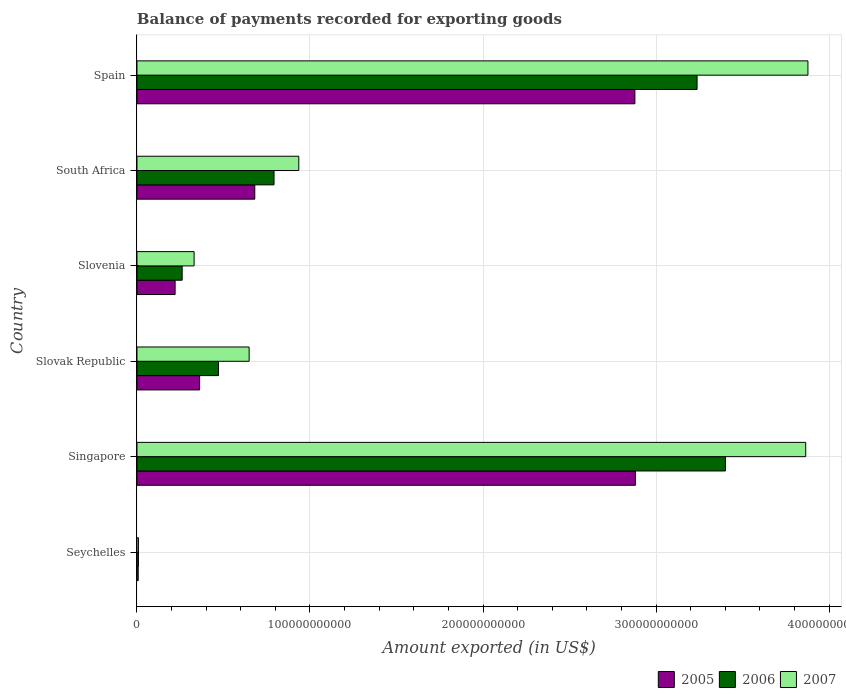Are the number of bars on each tick of the Y-axis equal?
Your answer should be compact. Yes. How many bars are there on the 4th tick from the bottom?
Provide a succinct answer. 3. What is the label of the 2nd group of bars from the top?
Offer a terse response. South Africa. In how many cases, is the number of bars for a given country not equal to the number of legend labels?
Your response must be concise. 0. What is the amount exported in 2005 in Slovak Republic?
Provide a succinct answer. 3.62e+1. Across all countries, what is the maximum amount exported in 2006?
Provide a succinct answer. 3.40e+11. Across all countries, what is the minimum amount exported in 2006?
Your response must be concise. 8.50e+08. In which country was the amount exported in 2007 maximum?
Your answer should be very brief. Spain. In which country was the amount exported in 2007 minimum?
Your answer should be compact. Seychelles. What is the total amount exported in 2005 in the graph?
Make the answer very short. 7.03e+11. What is the difference between the amount exported in 2007 in Singapore and that in Slovenia?
Give a very brief answer. 3.53e+11. What is the difference between the amount exported in 2006 in Slovenia and the amount exported in 2005 in Seychelles?
Make the answer very short. 2.54e+1. What is the average amount exported in 2006 per country?
Give a very brief answer. 1.36e+11. What is the difference between the amount exported in 2005 and amount exported in 2007 in Slovak Republic?
Offer a very short reply. -2.86e+1. In how many countries, is the amount exported in 2005 greater than 260000000000 US$?
Your answer should be very brief. 2. What is the ratio of the amount exported in 2005 in Seychelles to that in Spain?
Your answer should be very brief. 0. Is the amount exported in 2005 in South Africa less than that in Spain?
Provide a short and direct response. Yes. Is the difference between the amount exported in 2005 in Seychelles and Spain greater than the difference between the amount exported in 2007 in Seychelles and Spain?
Ensure brevity in your answer.  Yes. What is the difference between the highest and the second highest amount exported in 2007?
Your response must be concise. 1.29e+09. What is the difference between the highest and the lowest amount exported in 2007?
Keep it short and to the point. 3.87e+11. Is the sum of the amount exported in 2007 in Seychelles and Slovak Republic greater than the maximum amount exported in 2006 across all countries?
Provide a succinct answer. No. What does the 2nd bar from the top in Slovak Republic represents?
Keep it short and to the point. 2006. How many countries are there in the graph?
Ensure brevity in your answer.  6. What is the difference between two consecutive major ticks on the X-axis?
Provide a short and direct response. 1.00e+11. Are the values on the major ticks of X-axis written in scientific E-notation?
Your answer should be very brief. No. Does the graph contain any zero values?
Offer a terse response. No. What is the title of the graph?
Your response must be concise. Balance of payments recorded for exporting goods. Does "2006" appear as one of the legend labels in the graph?
Keep it short and to the point. Yes. What is the label or title of the X-axis?
Provide a short and direct response. Amount exported (in US$). What is the Amount exported (in US$) of 2005 in Seychelles?
Your answer should be very brief. 7.20e+08. What is the Amount exported (in US$) in 2006 in Seychelles?
Your response must be concise. 8.50e+08. What is the Amount exported (in US$) of 2007 in Seychelles?
Your answer should be compact. 8.54e+08. What is the Amount exported (in US$) of 2005 in Singapore?
Keep it short and to the point. 2.88e+11. What is the Amount exported (in US$) in 2006 in Singapore?
Ensure brevity in your answer.  3.40e+11. What is the Amount exported (in US$) in 2007 in Singapore?
Your answer should be compact. 3.86e+11. What is the Amount exported (in US$) in 2005 in Slovak Republic?
Your response must be concise. 3.62e+1. What is the Amount exported (in US$) of 2006 in Slovak Republic?
Provide a succinct answer. 4.71e+1. What is the Amount exported (in US$) of 2007 in Slovak Republic?
Provide a succinct answer. 6.48e+1. What is the Amount exported (in US$) in 2005 in Slovenia?
Your answer should be very brief. 2.21e+1. What is the Amount exported (in US$) in 2006 in Slovenia?
Keep it short and to the point. 2.61e+1. What is the Amount exported (in US$) in 2007 in Slovenia?
Offer a terse response. 3.30e+1. What is the Amount exported (in US$) of 2005 in South Africa?
Make the answer very short. 6.81e+1. What is the Amount exported (in US$) of 2006 in South Africa?
Your answer should be very brief. 7.92e+1. What is the Amount exported (in US$) in 2007 in South Africa?
Offer a terse response. 9.35e+1. What is the Amount exported (in US$) of 2005 in Spain?
Keep it short and to the point. 2.88e+11. What is the Amount exported (in US$) in 2006 in Spain?
Make the answer very short. 3.24e+11. What is the Amount exported (in US$) of 2007 in Spain?
Make the answer very short. 3.88e+11. Across all countries, what is the maximum Amount exported (in US$) of 2005?
Provide a succinct answer. 2.88e+11. Across all countries, what is the maximum Amount exported (in US$) of 2006?
Your answer should be very brief. 3.40e+11. Across all countries, what is the maximum Amount exported (in US$) in 2007?
Your answer should be very brief. 3.88e+11. Across all countries, what is the minimum Amount exported (in US$) in 2005?
Ensure brevity in your answer.  7.20e+08. Across all countries, what is the minimum Amount exported (in US$) of 2006?
Offer a terse response. 8.50e+08. Across all countries, what is the minimum Amount exported (in US$) of 2007?
Keep it short and to the point. 8.54e+08. What is the total Amount exported (in US$) of 2005 in the graph?
Keep it short and to the point. 7.03e+11. What is the total Amount exported (in US$) of 2006 in the graph?
Provide a succinct answer. 8.17e+11. What is the total Amount exported (in US$) of 2007 in the graph?
Your answer should be very brief. 9.67e+11. What is the difference between the Amount exported (in US$) in 2005 in Seychelles and that in Singapore?
Make the answer very short. -2.87e+11. What is the difference between the Amount exported (in US$) of 2006 in Seychelles and that in Singapore?
Your response must be concise. -3.39e+11. What is the difference between the Amount exported (in US$) in 2007 in Seychelles and that in Singapore?
Ensure brevity in your answer.  -3.86e+11. What is the difference between the Amount exported (in US$) of 2005 in Seychelles and that in Slovak Republic?
Give a very brief answer. -3.55e+1. What is the difference between the Amount exported (in US$) in 2006 in Seychelles and that in Slovak Republic?
Ensure brevity in your answer.  -4.63e+1. What is the difference between the Amount exported (in US$) of 2007 in Seychelles and that in Slovak Republic?
Make the answer very short. -6.40e+1. What is the difference between the Amount exported (in US$) of 2005 in Seychelles and that in Slovenia?
Keep it short and to the point. -2.13e+1. What is the difference between the Amount exported (in US$) of 2006 in Seychelles and that in Slovenia?
Provide a succinct answer. -2.53e+1. What is the difference between the Amount exported (in US$) of 2007 in Seychelles and that in Slovenia?
Offer a very short reply. -3.22e+1. What is the difference between the Amount exported (in US$) of 2005 in Seychelles and that in South Africa?
Your answer should be very brief. -6.74e+1. What is the difference between the Amount exported (in US$) in 2006 in Seychelles and that in South Africa?
Ensure brevity in your answer.  -7.84e+1. What is the difference between the Amount exported (in US$) in 2007 in Seychelles and that in South Africa?
Ensure brevity in your answer.  -9.27e+1. What is the difference between the Amount exported (in US$) of 2005 in Seychelles and that in Spain?
Your answer should be compact. -2.87e+11. What is the difference between the Amount exported (in US$) of 2006 in Seychelles and that in Spain?
Offer a terse response. -3.23e+11. What is the difference between the Amount exported (in US$) in 2007 in Seychelles and that in Spain?
Offer a very short reply. -3.87e+11. What is the difference between the Amount exported (in US$) of 2005 in Singapore and that in Slovak Republic?
Offer a terse response. 2.52e+11. What is the difference between the Amount exported (in US$) of 2006 in Singapore and that in Slovak Republic?
Offer a very short reply. 2.93e+11. What is the difference between the Amount exported (in US$) in 2007 in Singapore and that in Slovak Republic?
Your answer should be compact. 3.22e+11. What is the difference between the Amount exported (in US$) of 2005 in Singapore and that in Slovenia?
Ensure brevity in your answer.  2.66e+11. What is the difference between the Amount exported (in US$) of 2006 in Singapore and that in Slovenia?
Provide a succinct answer. 3.14e+11. What is the difference between the Amount exported (in US$) in 2007 in Singapore and that in Slovenia?
Offer a very short reply. 3.53e+11. What is the difference between the Amount exported (in US$) of 2005 in Singapore and that in South Africa?
Ensure brevity in your answer.  2.20e+11. What is the difference between the Amount exported (in US$) in 2006 in Singapore and that in South Africa?
Offer a very short reply. 2.61e+11. What is the difference between the Amount exported (in US$) in 2007 in Singapore and that in South Africa?
Keep it short and to the point. 2.93e+11. What is the difference between the Amount exported (in US$) in 2005 in Singapore and that in Spain?
Offer a very short reply. 2.99e+08. What is the difference between the Amount exported (in US$) of 2006 in Singapore and that in Spain?
Keep it short and to the point. 1.64e+1. What is the difference between the Amount exported (in US$) of 2007 in Singapore and that in Spain?
Ensure brevity in your answer.  -1.29e+09. What is the difference between the Amount exported (in US$) of 2005 in Slovak Republic and that in Slovenia?
Offer a terse response. 1.42e+1. What is the difference between the Amount exported (in US$) in 2006 in Slovak Republic and that in Slovenia?
Your answer should be very brief. 2.10e+1. What is the difference between the Amount exported (in US$) in 2007 in Slovak Republic and that in Slovenia?
Your answer should be very brief. 3.18e+1. What is the difference between the Amount exported (in US$) in 2005 in Slovak Republic and that in South Africa?
Provide a succinct answer. -3.19e+1. What is the difference between the Amount exported (in US$) of 2006 in Slovak Republic and that in South Africa?
Your answer should be very brief. -3.21e+1. What is the difference between the Amount exported (in US$) in 2007 in Slovak Republic and that in South Africa?
Provide a short and direct response. -2.87e+1. What is the difference between the Amount exported (in US$) of 2005 in Slovak Republic and that in Spain?
Provide a short and direct response. -2.52e+11. What is the difference between the Amount exported (in US$) of 2006 in Slovak Republic and that in Spain?
Provide a short and direct response. -2.77e+11. What is the difference between the Amount exported (in US$) in 2007 in Slovak Republic and that in Spain?
Ensure brevity in your answer.  -3.23e+11. What is the difference between the Amount exported (in US$) of 2005 in Slovenia and that in South Africa?
Offer a terse response. -4.60e+1. What is the difference between the Amount exported (in US$) of 2006 in Slovenia and that in South Africa?
Ensure brevity in your answer.  -5.31e+1. What is the difference between the Amount exported (in US$) in 2007 in Slovenia and that in South Africa?
Provide a short and direct response. -6.05e+1. What is the difference between the Amount exported (in US$) in 2005 in Slovenia and that in Spain?
Ensure brevity in your answer.  -2.66e+11. What is the difference between the Amount exported (in US$) of 2006 in Slovenia and that in Spain?
Offer a terse response. -2.98e+11. What is the difference between the Amount exported (in US$) of 2007 in Slovenia and that in Spain?
Offer a very short reply. -3.55e+11. What is the difference between the Amount exported (in US$) of 2005 in South Africa and that in Spain?
Your answer should be compact. -2.20e+11. What is the difference between the Amount exported (in US$) of 2006 in South Africa and that in Spain?
Your answer should be compact. -2.44e+11. What is the difference between the Amount exported (in US$) in 2007 in South Africa and that in Spain?
Your answer should be compact. -2.94e+11. What is the difference between the Amount exported (in US$) of 2005 in Seychelles and the Amount exported (in US$) of 2006 in Singapore?
Ensure brevity in your answer.  -3.39e+11. What is the difference between the Amount exported (in US$) in 2005 in Seychelles and the Amount exported (in US$) in 2007 in Singapore?
Make the answer very short. -3.86e+11. What is the difference between the Amount exported (in US$) of 2006 in Seychelles and the Amount exported (in US$) of 2007 in Singapore?
Your answer should be compact. -3.86e+11. What is the difference between the Amount exported (in US$) in 2005 in Seychelles and the Amount exported (in US$) in 2006 in Slovak Republic?
Your answer should be very brief. -4.64e+1. What is the difference between the Amount exported (in US$) of 2005 in Seychelles and the Amount exported (in US$) of 2007 in Slovak Republic?
Offer a very short reply. -6.41e+1. What is the difference between the Amount exported (in US$) in 2006 in Seychelles and the Amount exported (in US$) in 2007 in Slovak Republic?
Offer a terse response. -6.40e+1. What is the difference between the Amount exported (in US$) in 2005 in Seychelles and the Amount exported (in US$) in 2006 in Slovenia?
Make the answer very short. -2.54e+1. What is the difference between the Amount exported (in US$) of 2005 in Seychelles and the Amount exported (in US$) of 2007 in Slovenia?
Give a very brief answer. -3.23e+1. What is the difference between the Amount exported (in US$) of 2006 in Seychelles and the Amount exported (in US$) of 2007 in Slovenia?
Make the answer very short. -3.22e+1. What is the difference between the Amount exported (in US$) in 2005 in Seychelles and the Amount exported (in US$) in 2006 in South Africa?
Your response must be concise. -7.85e+1. What is the difference between the Amount exported (in US$) in 2005 in Seychelles and the Amount exported (in US$) in 2007 in South Africa?
Your response must be concise. -9.28e+1. What is the difference between the Amount exported (in US$) in 2006 in Seychelles and the Amount exported (in US$) in 2007 in South Africa?
Make the answer very short. -9.27e+1. What is the difference between the Amount exported (in US$) of 2005 in Seychelles and the Amount exported (in US$) of 2006 in Spain?
Ensure brevity in your answer.  -3.23e+11. What is the difference between the Amount exported (in US$) of 2005 in Seychelles and the Amount exported (in US$) of 2007 in Spain?
Offer a terse response. -3.87e+11. What is the difference between the Amount exported (in US$) of 2006 in Seychelles and the Amount exported (in US$) of 2007 in Spain?
Your answer should be compact. -3.87e+11. What is the difference between the Amount exported (in US$) of 2005 in Singapore and the Amount exported (in US$) of 2006 in Slovak Republic?
Offer a very short reply. 2.41e+11. What is the difference between the Amount exported (in US$) of 2005 in Singapore and the Amount exported (in US$) of 2007 in Slovak Republic?
Your answer should be very brief. 2.23e+11. What is the difference between the Amount exported (in US$) in 2006 in Singapore and the Amount exported (in US$) in 2007 in Slovak Republic?
Provide a short and direct response. 2.75e+11. What is the difference between the Amount exported (in US$) of 2005 in Singapore and the Amount exported (in US$) of 2006 in Slovenia?
Provide a succinct answer. 2.62e+11. What is the difference between the Amount exported (in US$) in 2005 in Singapore and the Amount exported (in US$) in 2007 in Slovenia?
Provide a short and direct response. 2.55e+11. What is the difference between the Amount exported (in US$) of 2006 in Singapore and the Amount exported (in US$) of 2007 in Slovenia?
Provide a short and direct response. 3.07e+11. What is the difference between the Amount exported (in US$) of 2005 in Singapore and the Amount exported (in US$) of 2006 in South Africa?
Keep it short and to the point. 2.09e+11. What is the difference between the Amount exported (in US$) of 2005 in Singapore and the Amount exported (in US$) of 2007 in South Africa?
Your answer should be very brief. 1.95e+11. What is the difference between the Amount exported (in US$) of 2006 in Singapore and the Amount exported (in US$) of 2007 in South Africa?
Give a very brief answer. 2.47e+11. What is the difference between the Amount exported (in US$) in 2005 in Singapore and the Amount exported (in US$) in 2006 in Spain?
Provide a short and direct response. -3.56e+1. What is the difference between the Amount exported (in US$) in 2005 in Singapore and the Amount exported (in US$) in 2007 in Spain?
Offer a very short reply. -9.97e+1. What is the difference between the Amount exported (in US$) in 2006 in Singapore and the Amount exported (in US$) in 2007 in Spain?
Keep it short and to the point. -4.77e+1. What is the difference between the Amount exported (in US$) of 2005 in Slovak Republic and the Amount exported (in US$) of 2006 in Slovenia?
Give a very brief answer. 1.01e+1. What is the difference between the Amount exported (in US$) of 2005 in Slovak Republic and the Amount exported (in US$) of 2007 in Slovenia?
Ensure brevity in your answer.  3.18e+09. What is the difference between the Amount exported (in US$) of 2006 in Slovak Republic and the Amount exported (in US$) of 2007 in Slovenia?
Your response must be concise. 1.41e+1. What is the difference between the Amount exported (in US$) of 2005 in Slovak Republic and the Amount exported (in US$) of 2006 in South Africa?
Provide a short and direct response. -4.30e+1. What is the difference between the Amount exported (in US$) in 2005 in Slovak Republic and the Amount exported (in US$) in 2007 in South Africa?
Keep it short and to the point. -5.73e+1. What is the difference between the Amount exported (in US$) in 2006 in Slovak Republic and the Amount exported (in US$) in 2007 in South Africa?
Keep it short and to the point. -4.64e+1. What is the difference between the Amount exported (in US$) in 2005 in Slovak Republic and the Amount exported (in US$) in 2006 in Spain?
Offer a very short reply. -2.87e+11. What is the difference between the Amount exported (in US$) in 2005 in Slovak Republic and the Amount exported (in US$) in 2007 in Spain?
Provide a succinct answer. -3.52e+11. What is the difference between the Amount exported (in US$) in 2006 in Slovak Republic and the Amount exported (in US$) in 2007 in Spain?
Your response must be concise. -3.41e+11. What is the difference between the Amount exported (in US$) of 2005 in Slovenia and the Amount exported (in US$) of 2006 in South Africa?
Your answer should be compact. -5.72e+1. What is the difference between the Amount exported (in US$) in 2005 in Slovenia and the Amount exported (in US$) in 2007 in South Africa?
Your response must be concise. -7.15e+1. What is the difference between the Amount exported (in US$) in 2006 in Slovenia and the Amount exported (in US$) in 2007 in South Africa?
Your answer should be compact. -6.74e+1. What is the difference between the Amount exported (in US$) of 2005 in Slovenia and the Amount exported (in US$) of 2006 in Spain?
Provide a succinct answer. -3.02e+11. What is the difference between the Amount exported (in US$) of 2005 in Slovenia and the Amount exported (in US$) of 2007 in Spain?
Give a very brief answer. -3.66e+11. What is the difference between the Amount exported (in US$) in 2006 in Slovenia and the Amount exported (in US$) in 2007 in Spain?
Make the answer very short. -3.62e+11. What is the difference between the Amount exported (in US$) of 2005 in South Africa and the Amount exported (in US$) of 2006 in Spain?
Ensure brevity in your answer.  -2.56e+11. What is the difference between the Amount exported (in US$) of 2005 in South Africa and the Amount exported (in US$) of 2007 in Spain?
Offer a very short reply. -3.20e+11. What is the difference between the Amount exported (in US$) in 2006 in South Africa and the Amount exported (in US$) in 2007 in Spain?
Provide a succinct answer. -3.09e+11. What is the average Amount exported (in US$) in 2005 per country?
Make the answer very short. 1.17e+11. What is the average Amount exported (in US$) of 2006 per country?
Offer a terse response. 1.36e+11. What is the average Amount exported (in US$) in 2007 per country?
Offer a very short reply. 1.61e+11. What is the difference between the Amount exported (in US$) of 2005 and Amount exported (in US$) of 2006 in Seychelles?
Keep it short and to the point. -1.31e+08. What is the difference between the Amount exported (in US$) of 2005 and Amount exported (in US$) of 2007 in Seychelles?
Keep it short and to the point. -1.34e+08. What is the difference between the Amount exported (in US$) of 2006 and Amount exported (in US$) of 2007 in Seychelles?
Offer a terse response. -3.37e+06. What is the difference between the Amount exported (in US$) in 2005 and Amount exported (in US$) in 2006 in Singapore?
Keep it short and to the point. -5.20e+1. What is the difference between the Amount exported (in US$) of 2005 and Amount exported (in US$) of 2007 in Singapore?
Provide a succinct answer. -9.84e+1. What is the difference between the Amount exported (in US$) in 2006 and Amount exported (in US$) in 2007 in Singapore?
Your response must be concise. -4.64e+1. What is the difference between the Amount exported (in US$) in 2005 and Amount exported (in US$) in 2006 in Slovak Republic?
Offer a very short reply. -1.09e+1. What is the difference between the Amount exported (in US$) in 2005 and Amount exported (in US$) in 2007 in Slovak Republic?
Your response must be concise. -2.86e+1. What is the difference between the Amount exported (in US$) in 2006 and Amount exported (in US$) in 2007 in Slovak Republic?
Provide a short and direct response. -1.77e+1. What is the difference between the Amount exported (in US$) in 2005 and Amount exported (in US$) in 2006 in Slovenia?
Offer a terse response. -4.07e+09. What is the difference between the Amount exported (in US$) in 2005 and Amount exported (in US$) in 2007 in Slovenia?
Offer a terse response. -1.10e+1. What is the difference between the Amount exported (in US$) in 2006 and Amount exported (in US$) in 2007 in Slovenia?
Ensure brevity in your answer.  -6.91e+09. What is the difference between the Amount exported (in US$) in 2005 and Amount exported (in US$) in 2006 in South Africa?
Provide a short and direct response. -1.11e+1. What is the difference between the Amount exported (in US$) in 2005 and Amount exported (in US$) in 2007 in South Africa?
Your response must be concise. -2.54e+1. What is the difference between the Amount exported (in US$) in 2006 and Amount exported (in US$) in 2007 in South Africa?
Give a very brief answer. -1.43e+1. What is the difference between the Amount exported (in US$) of 2005 and Amount exported (in US$) of 2006 in Spain?
Make the answer very short. -3.59e+1. What is the difference between the Amount exported (in US$) of 2005 and Amount exported (in US$) of 2007 in Spain?
Your response must be concise. -1.00e+11. What is the difference between the Amount exported (in US$) of 2006 and Amount exported (in US$) of 2007 in Spain?
Your answer should be compact. -6.41e+1. What is the ratio of the Amount exported (in US$) of 2005 in Seychelles to that in Singapore?
Your response must be concise. 0. What is the ratio of the Amount exported (in US$) of 2006 in Seychelles to that in Singapore?
Your response must be concise. 0. What is the ratio of the Amount exported (in US$) of 2007 in Seychelles to that in Singapore?
Give a very brief answer. 0. What is the ratio of the Amount exported (in US$) in 2005 in Seychelles to that in Slovak Republic?
Your answer should be compact. 0.02. What is the ratio of the Amount exported (in US$) in 2006 in Seychelles to that in Slovak Republic?
Provide a succinct answer. 0.02. What is the ratio of the Amount exported (in US$) of 2007 in Seychelles to that in Slovak Republic?
Your response must be concise. 0.01. What is the ratio of the Amount exported (in US$) of 2005 in Seychelles to that in Slovenia?
Your response must be concise. 0.03. What is the ratio of the Amount exported (in US$) of 2006 in Seychelles to that in Slovenia?
Provide a short and direct response. 0.03. What is the ratio of the Amount exported (in US$) of 2007 in Seychelles to that in Slovenia?
Your response must be concise. 0.03. What is the ratio of the Amount exported (in US$) of 2005 in Seychelles to that in South Africa?
Keep it short and to the point. 0.01. What is the ratio of the Amount exported (in US$) in 2006 in Seychelles to that in South Africa?
Your answer should be very brief. 0.01. What is the ratio of the Amount exported (in US$) of 2007 in Seychelles to that in South Africa?
Your answer should be very brief. 0.01. What is the ratio of the Amount exported (in US$) in 2005 in Seychelles to that in Spain?
Make the answer very short. 0. What is the ratio of the Amount exported (in US$) of 2006 in Seychelles to that in Spain?
Your response must be concise. 0. What is the ratio of the Amount exported (in US$) in 2007 in Seychelles to that in Spain?
Give a very brief answer. 0. What is the ratio of the Amount exported (in US$) of 2005 in Singapore to that in Slovak Republic?
Offer a very short reply. 7.95. What is the ratio of the Amount exported (in US$) in 2006 in Singapore to that in Slovak Republic?
Give a very brief answer. 7.22. What is the ratio of the Amount exported (in US$) of 2007 in Singapore to that in Slovak Republic?
Make the answer very short. 5.96. What is the ratio of the Amount exported (in US$) of 2005 in Singapore to that in Slovenia?
Your answer should be very brief. 13.06. What is the ratio of the Amount exported (in US$) of 2006 in Singapore to that in Slovenia?
Your answer should be very brief. 13.02. What is the ratio of the Amount exported (in US$) in 2007 in Singapore to that in Slovenia?
Keep it short and to the point. 11.7. What is the ratio of the Amount exported (in US$) of 2005 in Singapore to that in South Africa?
Provide a succinct answer. 4.23. What is the ratio of the Amount exported (in US$) in 2006 in Singapore to that in South Africa?
Offer a very short reply. 4.29. What is the ratio of the Amount exported (in US$) of 2007 in Singapore to that in South Africa?
Your answer should be compact. 4.13. What is the ratio of the Amount exported (in US$) in 2006 in Singapore to that in Spain?
Give a very brief answer. 1.05. What is the ratio of the Amount exported (in US$) of 2007 in Singapore to that in Spain?
Give a very brief answer. 1. What is the ratio of the Amount exported (in US$) of 2005 in Slovak Republic to that in Slovenia?
Your answer should be compact. 1.64. What is the ratio of the Amount exported (in US$) in 2006 in Slovak Republic to that in Slovenia?
Offer a very short reply. 1.8. What is the ratio of the Amount exported (in US$) of 2007 in Slovak Republic to that in Slovenia?
Offer a very short reply. 1.96. What is the ratio of the Amount exported (in US$) in 2005 in Slovak Republic to that in South Africa?
Offer a very short reply. 0.53. What is the ratio of the Amount exported (in US$) in 2006 in Slovak Republic to that in South Africa?
Make the answer very short. 0.59. What is the ratio of the Amount exported (in US$) of 2007 in Slovak Republic to that in South Africa?
Your response must be concise. 0.69. What is the ratio of the Amount exported (in US$) of 2005 in Slovak Republic to that in Spain?
Offer a very short reply. 0.13. What is the ratio of the Amount exported (in US$) in 2006 in Slovak Republic to that in Spain?
Provide a succinct answer. 0.15. What is the ratio of the Amount exported (in US$) of 2007 in Slovak Republic to that in Spain?
Offer a terse response. 0.17. What is the ratio of the Amount exported (in US$) in 2005 in Slovenia to that in South Africa?
Offer a terse response. 0.32. What is the ratio of the Amount exported (in US$) in 2006 in Slovenia to that in South Africa?
Your answer should be very brief. 0.33. What is the ratio of the Amount exported (in US$) in 2007 in Slovenia to that in South Africa?
Keep it short and to the point. 0.35. What is the ratio of the Amount exported (in US$) of 2005 in Slovenia to that in Spain?
Give a very brief answer. 0.08. What is the ratio of the Amount exported (in US$) in 2006 in Slovenia to that in Spain?
Make the answer very short. 0.08. What is the ratio of the Amount exported (in US$) in 2007 in Slovenia to that in Spain?
Your response must be concise. 0.09. What is the ratio of the Amount exported (in US$) in 2005 in South Africa to that in Spain?
Your answer should be very brief. 0.24. What is the ratio of the Amount exported (in US$) of 2006 in South Africa to that in Spain?
Keep it short and to the point. 0.24. What is the ratio of the Amount exported (in US$) in 2007 in South Africa to that in Spain?
Ensure brevity in your answer.  0.24. What is the difference between the highest and the second highest Amount exported (in US$) in 2005?
Provide a succinct answer. 2.99e+08. What is the difference between the highest and the second highest Amount exported (in US$) in 2006?
Keep it short and to the point. 1.64e+1. What is the difference between the highest and the second highest Amount exported (in US$) of 2007?
Make the answer very short. 1.29e+09. What is the difference between the highest and the lowest Amount exported (in US$) of 2005?
Provide a short and direct response. 2.87e+11. What is the difference between the highest and the lowest Amount exported (in US$) in 2006?
Give a very brief answer. 3.39e+11. What is the difference between the highest and the lowest Amount exported (in US$) in 2007?
Your response must be concise. 3.87e+11. 